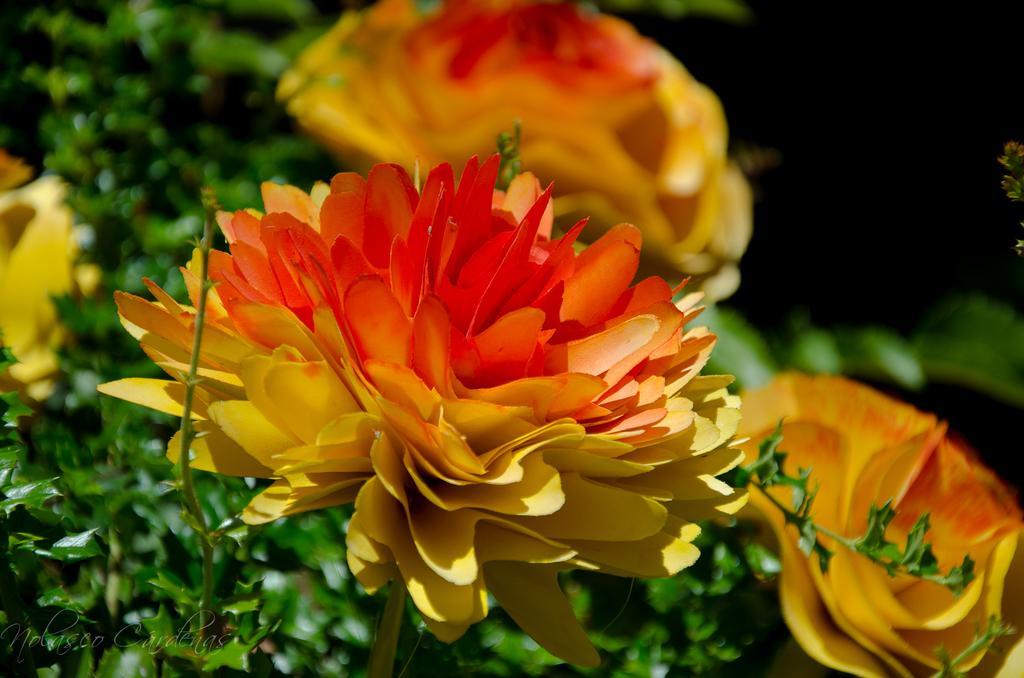Can you describe this image briefly? In this picture we can see the flowers and plants. In the bottom left corner we can see the text. In the top right corner the image is dark. 